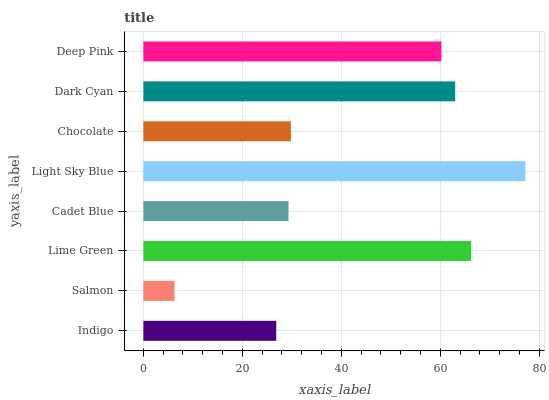Is Salmon the minimum?
Answer yes or no. Yes. Is Light Sky Blue the maximum?
Answer yes or no. Yes. Is Lime Green the minimum?
Answer yes or no. No. Is Lime Green the maximum?
Answer yes or no. No. Is Lime Green greater than Salmon?
Answer yes or no. Yes. Is Salmon less than Lime Green?
Answer yes or no. Yes. Is Salmon greater than Lime Green?
Answer yes or no. No. Is Lime Green less than Salmon?
Answer yes or no. No. Is Deep Pink the high median?
Answer yes or no. Yes. Is Chocolate the low median?
Answer yes or no. Yes. Is Chocolate the high median?
Answer yes or no. No. Is Lime Green the low median?
Answer yes or no. No. 